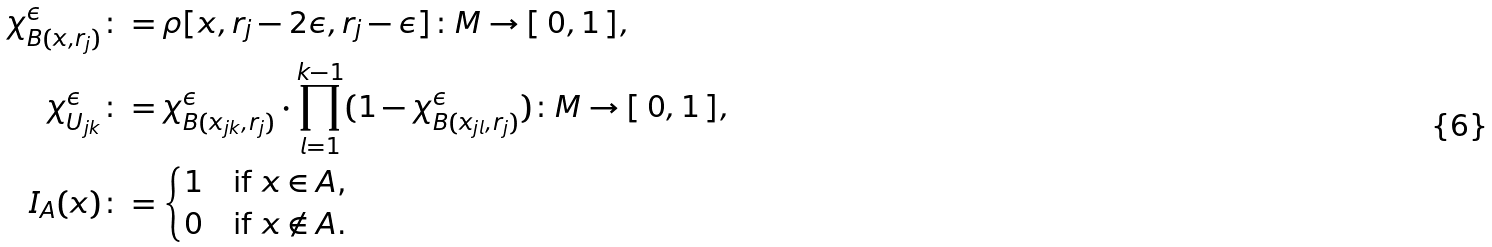<formula> <loc_0><loc_0><loc_500><loc_500>\chi _ { B ( x , r _ { j } ) } ^ { \epsilon } & \colon = \rho [ x , r _ { j } - 2 \epsilon , r _ { j } - \epsilon ] \colon M \to [ \, 0 , 1 \, ] , \\ \chi _ { U _ { j k } } ^ { \epsilon } & \colon = \chi _ { B ( x _ { j k } , r _ { j } ) } ^ { \epsilon } \cdot \prod _ { l = 1 } ^ { k - 1 } ( 1 - \chi _ { B ( x _ { j l } , r _ { j } ) } ^ { \epsilon } ) \colon M \to [ \, 0 , 1 \, ] , \\ I _ { A } ( x ) & \colon = \begin{cases} 1 & \text {if $x \in A$,} \\ 0 & \text {if $x \notin A$.} \end{cases}</formula> 